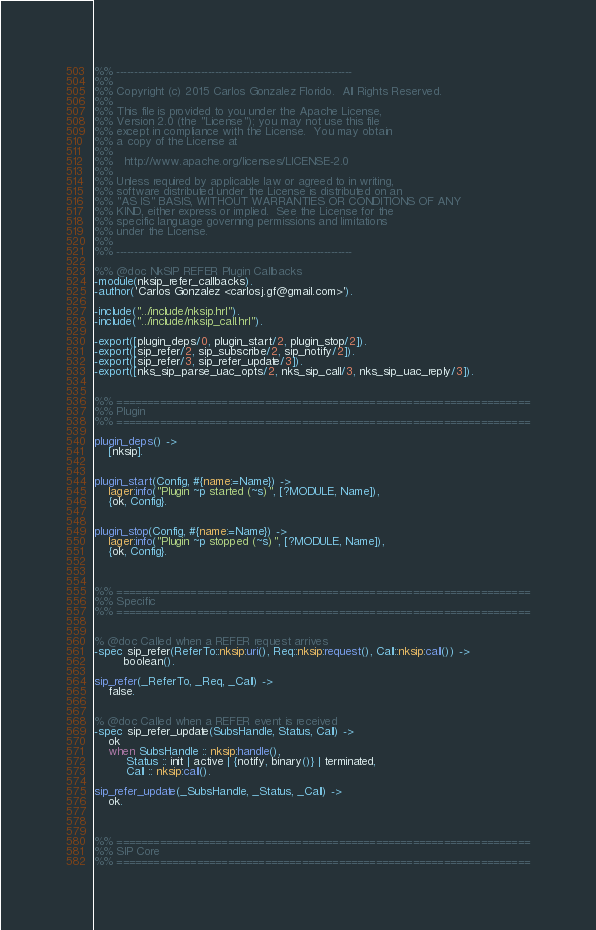<code> <loc_0><loc_0><loc_500><loc_500><_Erlang_>%% -------------------------------------------------------------------
%%
%% Copyright (c) 2015 Carlos Gonzalez Florido.  All Rights Reserved.
%%
%% This file is provided to you under the Apache License,
%% Version 2.0 (the "License"); you may not use this file
%% except in compliance with the License.  You may obtain
%% a copy of the License at
%%
%%   http://www.apache.org/licenses/LICENSE-2.0
%%
%% Unless required by applicable law or agreed to in writing,
%% software distributed under the License is distributed on an
%% "AS IS" BASIS, WITHOUT WARRANTIES OR CONDITIONS OF ANY
%% KIND, either express or implied.  See the License for the
%% specific language governing permissions and limitations
%% under the License.
%%
%% -------------------------------------------------------------------

%% @doc NkSIP REFER Plugin Callbacks
-module(nksip_refer_callbacks).
-author('Carlos Gonzalez <carlosj.gf@gmail.com>').

-include("../include/nksip.hrl").
-include("../include/nksip_call.hrl").

-export([plugin_deps/0, plugin_start/2, plugin_stop/2]).
-export([sip_refer/2, sip_subscribe/2, sip_notify/2]).
-export([sip_refer/3, sip_refer_update/3]).
-export([nks_sip_parse_uac_opts/2, nks_sip_call/3, nks_sip_uac_reply/3]).


%% ===================================================================
%% Plugin
%% ===================================================================

plugin_deps() ->
    [nksip].


plugin_start(Config, #{name:=Name}) ->
    lager:info("Plugin ~p started (~s)", [?MODULE, Name]),
    {ok, Config}.


plugin_stop(Config, #{name:=Name}) ->
    lager:info("Plugin ~p stopped (~s)", [?MODULE, Name]),
    {ok, Config}.



%% ===================================================================
%% Specific
%% ===================================================================


% @doc Called when a REFER request arrives
-spec sip_refer(ReferTo::nksip:uri(), Req::nksip:request(), Call::nksip:call()) ->
        boolean().

sip_refer(_ReferTo, _Req, _Call) ->
    false.
    

% @doc Called when a REFER event is received
-spec sip_refer_update(SubsHandle, Status, Call) ->
    ok
    when SubsHandle :: nksip:handle(), 
         Status :: init | active | {notify, binary()} | terminated,
         Call :: nksip:call().

sip_refer_update(_SubsHandle, _Status, _Call) ->
    ok.



%% ===================================================================
%% SIP Core
%% ===================================================================

</code> 